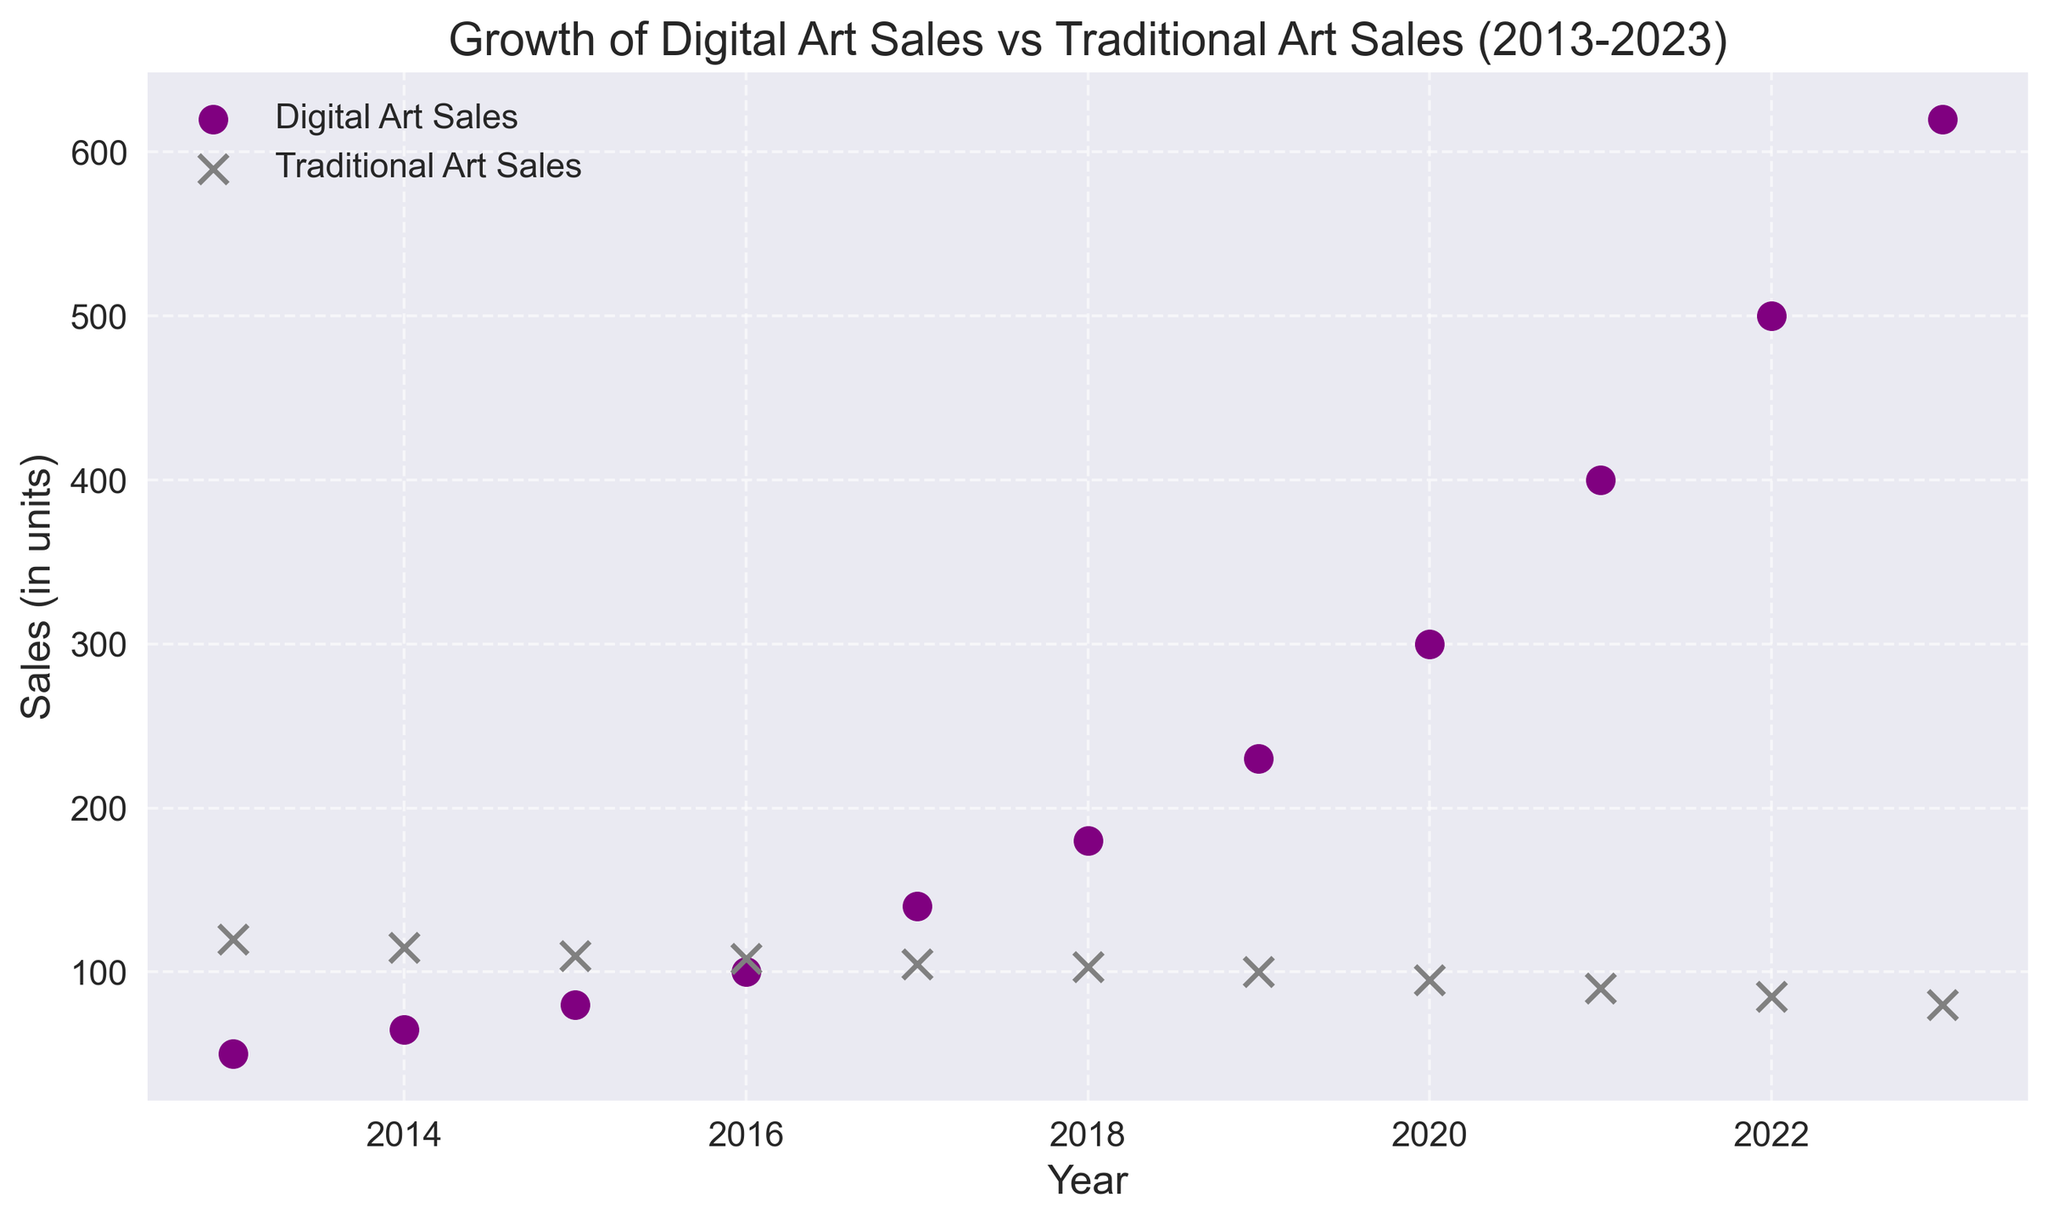What is the trend of digital art sales over the ten-year period? From the plot, you can observe that the digital art sales have increased steadily year by year from 50 units in 2013 to 620 units in 2023.
Answer: Increasing How do the 2023 sales figures for digital art and traditional art compare? In the plot, you can see that digital art sales in 2023 are significantly higher than traditional art sales. Digital art sales are 620 units, whereas traditional art sales are 80 units.
Answer: Digital art sales are higher What are the total digital art sales and traditional art sales combined for 2017? According to the plot, the digital art sales in 2017 are 140 units and traditional art sales are 105 units. Adding them together gives 140 + 105 = 245 units.
Answer: 245 units In which year did digital art sales surpass 200 units? By inspecting the plot, digital art sales surpassed 200 units in the year 2019, where the sales were 230 units.
Answer: 2019 How does the trend of traditional art sales differ from that of digital art sales across the years? While digital art sales show an increasing trend through the years, traditional art sales show a declining trend. Digital art sales see a consistent rise, whereas traditional art sales steadily decrease from 120 units in 2013 to 80 units in 2023.
Answer: Digital art increasing, traditional art decreasing Which color represents digital art sales in the plot? The plot uses a purple color to represent the digital art sales scatter points.
Answer: Purple How much did digital art sales increase from 2018 to 2020? In 2018, digital art sales were 180 units, and in 2020, they were 300 units. The increase is calculated by subtracting the 2018 sales from the 2020 sales: 300 - 180 = 120 units.
Answer: 120 units During which year were traditional art sales closest to digital art sales? By visual inspection, traditional and digital art sales were closest in 2016. Digital art sales were 100 units and traditional art sales were 108 units, a difference of 8 units.
Answer: 2016 What is the average digital art sales over the entire period shown in the plot? Sum all the digital art sales from each year (50 + 65 + 80 + 100 + 140 + 180 + 230 + 300 + 400 + 500 + 620 = 2665 units). Divide this by the number of years (11). 2665 / 11 ≈ 242.27 units.
Answer: 242.27 units Compare the sales trends of traditional and digital art in 2014 and 2022. In 2014, digital art sales were 65 units compared to traditional art sales of 115 units; traditional art sales were higher. By 2022, digital art sales have surged to 500 units, while traditional art sales decreased to 85 units, showing digital art sales are now substantially higher.
Answer: Digital art initially lower, then became substantially higher 